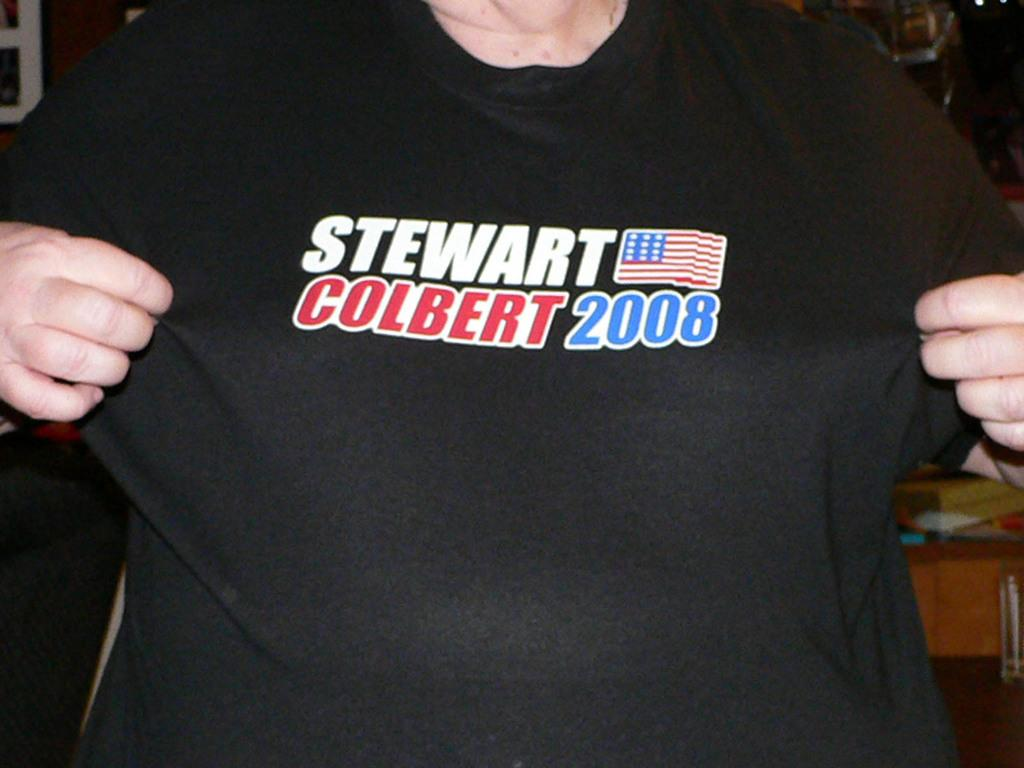Who is present in the image? There is a person in the image. What is the person wearing? The person is wearing a black shirt. What can be seen in the background of the image? There is a table in the background of the image. What is placed on the table? There are things placed on the table. What type of texture does the person's creator have in the image? There is no mention of a creator in the image, and therefore we cannot determine the texture of their creator. 